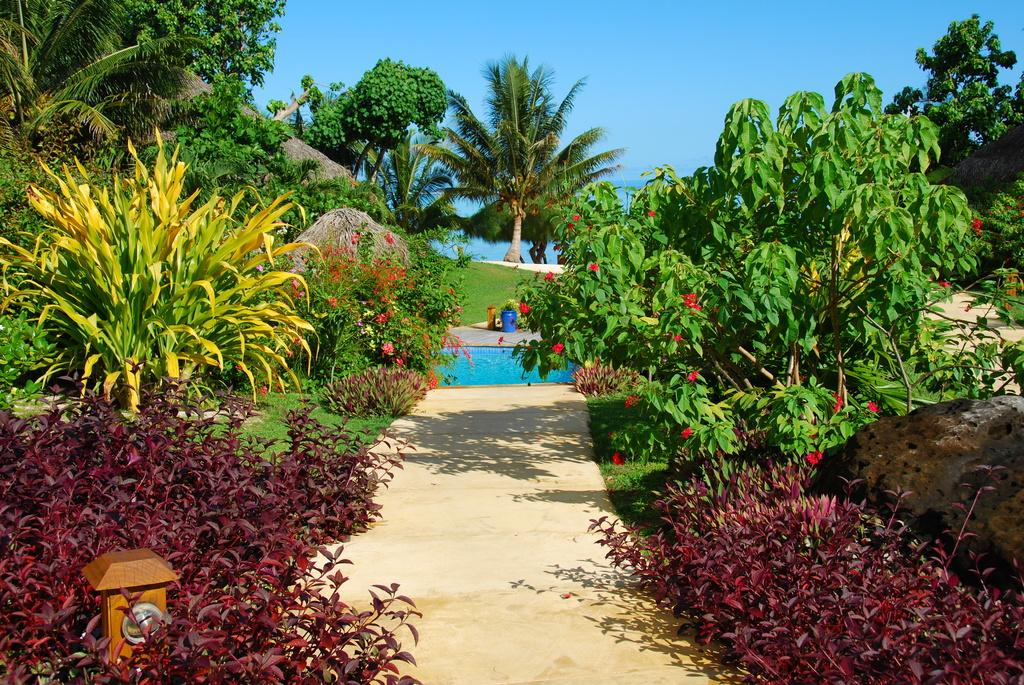What type of plants can be seen in the image? There are plants with flowers in the image. What other natural elements are present in the image? There are trees in the image. What man-made object can be seen for waste disposal? There is a dustbin in the image. What recreational feature is visible in the image? There is a swimming pool in the image. What is visible in the background of the image? The sky is visible in the background of the image. What object is on the left side of the image? There is a wooden pole on the left side of the image. What type of competition is taking place in the image? There is no competition present in the image. What type of cabbage can be seen growing in the image? There is no cabbage present in the image. 